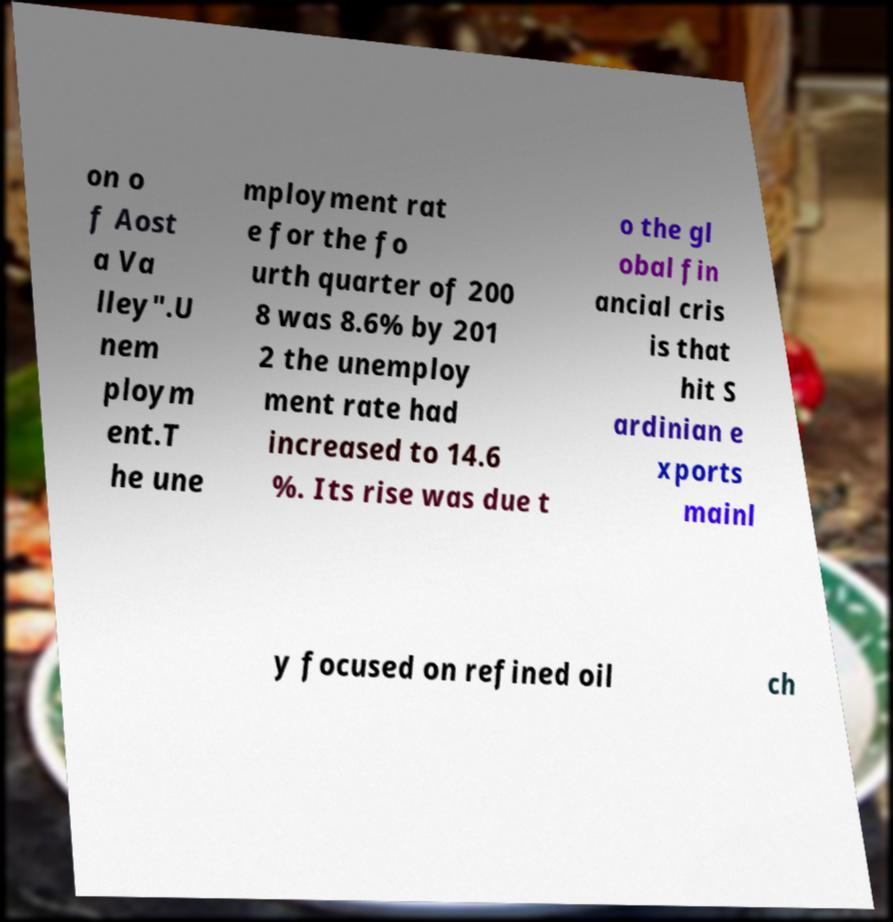Can you read and provide the text displayed in the image?This photo seems to have some interesting text. Can you extract and type it out for me? on o f Aost a Va lley".U nem ploym ent.T he une mployment rat e for the fo urth quarter of 200 8 was 8.6% by 201 2 the unemploy ment rate had increased to 14.6 %. Its rise was due t o the gl obal fin ancial cris is that hit S ardinian e xports mainl y focused on refined oil ch 